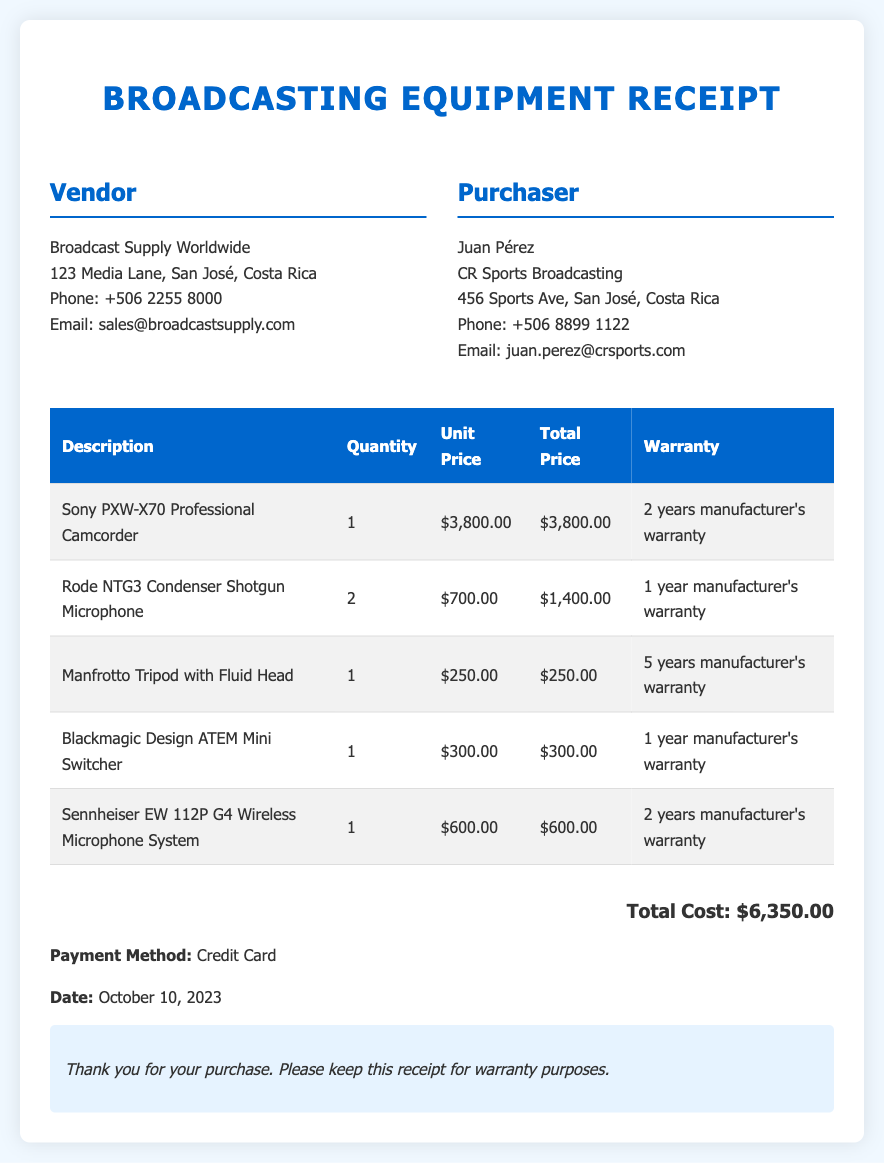what is the total cost? The total cost is presented in the document as the sum of all item prices, which is $6,350.00.
Answer: $6,350.00 who is the vendor? The vendor's name is mentioned in the document, which is Broadcast Supply Worldwide.
Answer: Broadcast Supply Worldwide how many Rode NTG3 microphones were purchased? The quantity of Rode NTG3 microphones is provided in the itemized list, which is 2.
Answer: 2 what is the warranty for the Manfrotto Tripod with Fluid Head? The warranty for the Manfrotto Tripod is specified in the document as 5 years manufacturer's warranty.
Answer: 5 years manufacturer's warranty what payment method was used? The document specifies the payment method used for the transaction, which is Credit Card.
Answer: Credit Card what is the date of the purchase? The date of the purchase is clearly noted in the document as October 10, 2023.
Answer: October 10, 2023 how many items were listed in the purchase? The document lists a total of 5 different items acquired during the purchase.
Answer: 5 what is the warranty period for the Sony PXW-X70 Professional Camcorder? The warranty period for the Sony PXW-X70 is mentioned in the document as 2 years manufacturer's warranty.
Answer: 2 years manufacturer's warranty what was purchased alongside the Blackmagic Design ATEM Mini Switcher? The document lists the items, revealing that the Sennheiser EW 112P G4 Wireless Microphone System was purchased alongside it.
Answer: Sennheiser EW 112P G4 Wireless Microphone System 